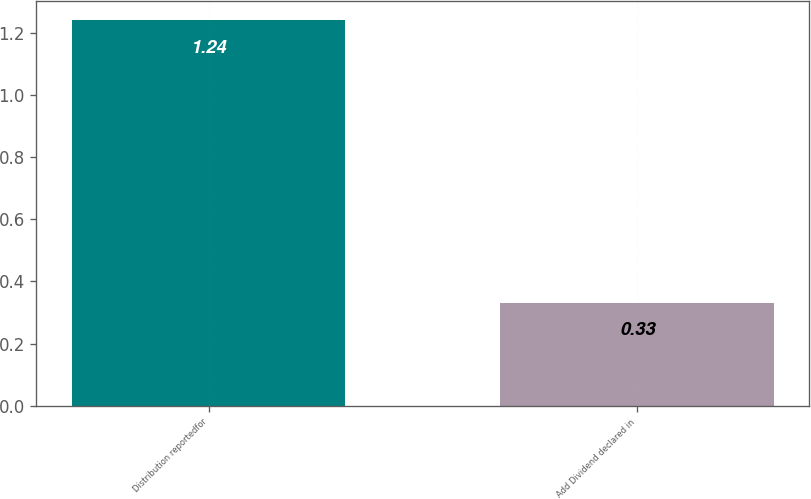Convert chart to OTSL. <chart><loc_0><loc_0><loc_500><loc_500><bar_chart><fcel>Distribution reportedfor<fcel>Add Dividend declared in<nl><fcel>1.24<fcel>0.33<nl></chart> 